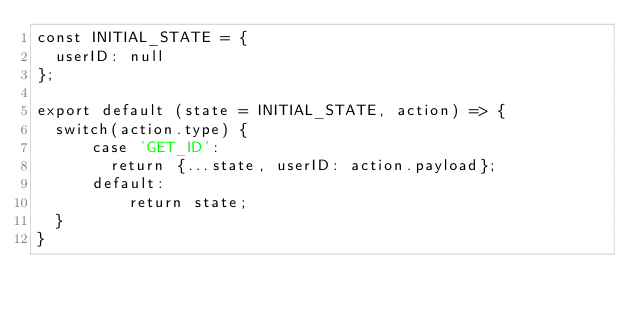Convert code to text. <code><loc_0><loc_0><loc_500><loc_500><_JavaScript_>const INITIAL_STATE = {
  userID: null
};

export default (state = INITIAL_STATE, action) => {
  switch(action.type) {
      case 'GET_ID':
        return {...state, userID: action.payload};
      default:
          return state;
  }
}</code> 